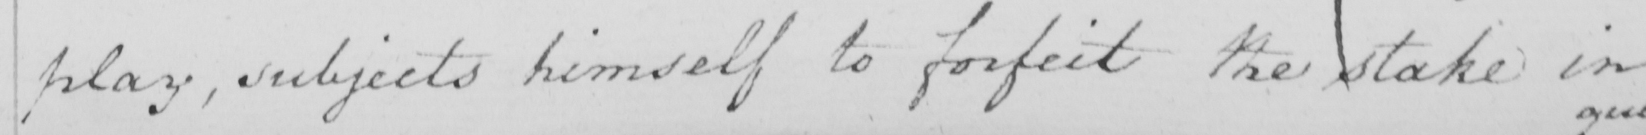What does this handwritten line say? play , subjects himself to forfeit the stake in 